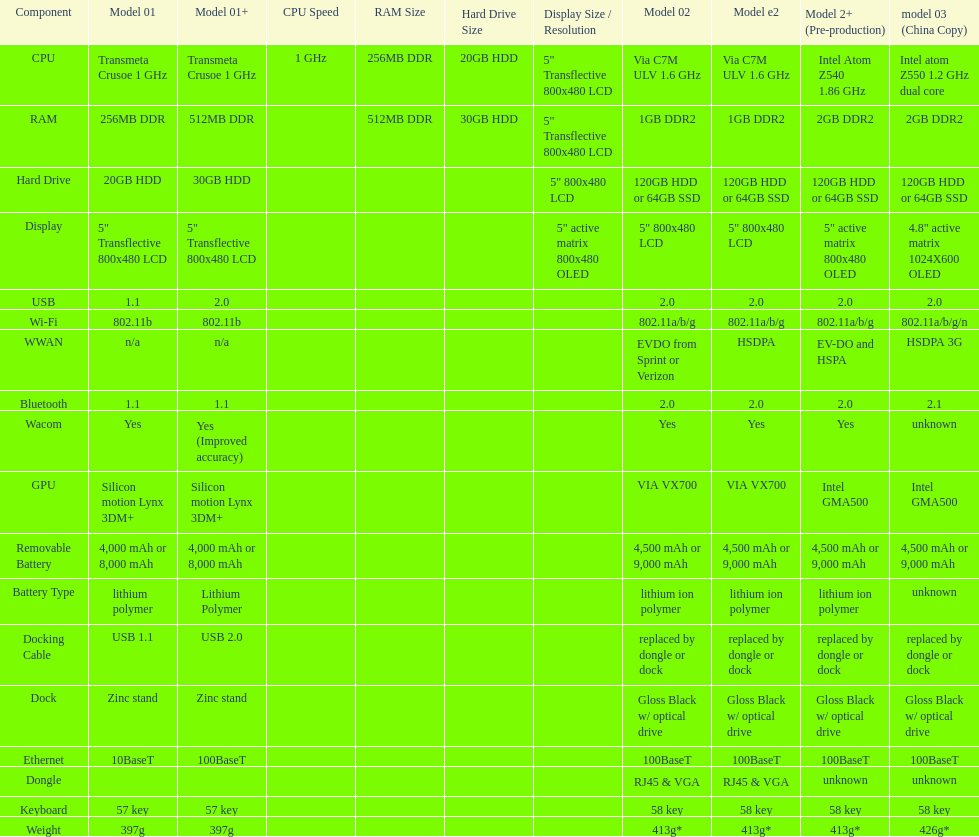How much more weight does the model 3 have over model 1? 29g. 